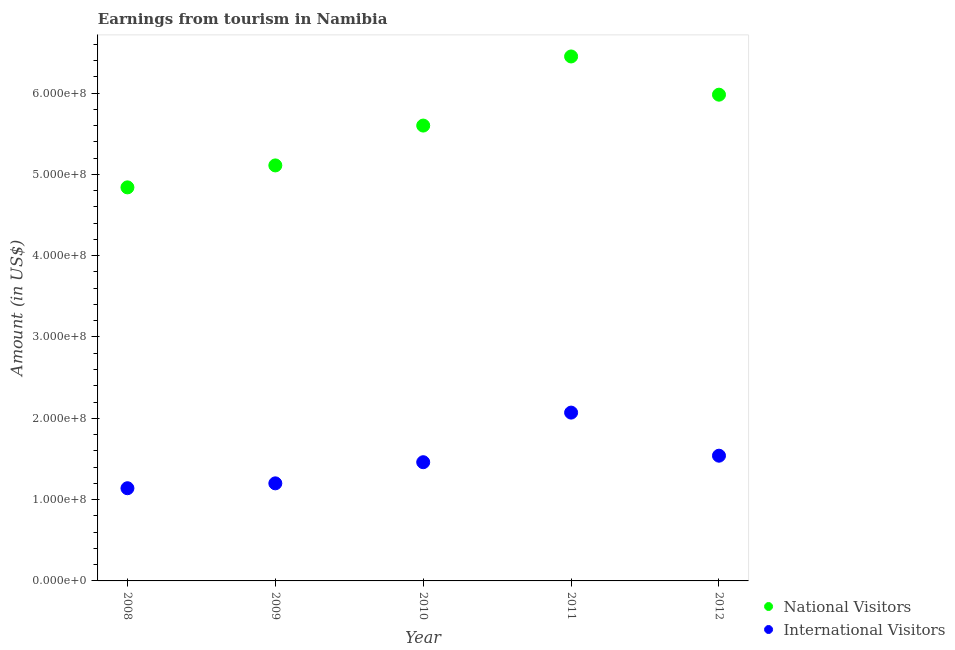How many different coloured dotlines are there?
Provide a succinct answer. 2. Is the number of dotlines equal to the number of legend labels?
Your answer should be very brief. Yes. What is the amount earned from international visitors in 2008?
Your answer should be compact. 1.14e+08. Across all years, what is the maximum amount earned from national visitors?
Ensure brevity in your answer.  6.45e+08. Across all years, what is the minimum amount earned from national visitors?
Offer a very short reply. 4.84e+08. In which year was the amount earned from national visitors maximum?
Offer a terse response. 2011. What is the total amount earned from national visitors in the graph?
Keep it short and to the point. 2.80e+09. What is the difference between the amount earned from international visitors in 2010 and that in 2012?
Your answer should be very brief. -8.00e+06. What is the difference between the amount earned from national visitors in 2011 and the amount earned from international visitors in 2010?
Make the answer very short. 4.99e+08. What is the average amount earned from international visitors per year?
Provide a succinct answer. 1.48e+08. In the year 2010, what is the difference between the amount earned from international visitors and amount earned from national visitors?
Give a very brief answer. -4.14e+08. What is the ratio of the amount earned from national visitors in 2008 to that in 2011?
Your answer should be compact. 0.75. What is the difference between the highest and the second highest amount earned from international visitors?
Ensure brevity in your answer.  5.30e+07. What is the difference between the highest and the lowest amount earned from national visitors?
Keep it short and to the point. 1.61e+08. In how many years, is the amount earned from national visitors greater than the average amount earned from national visitors taken over all years?
Give a very brief answer. 3. Is the sum of the amount earned from international visitors in 2008 and 2012 greater than the maximum amount earned from national visitors across all years?
Offer a terse response. No. Does the amount earned from international visitors monotonically increase over the years?
Make the answer very short. No. How many years are there in the graph?
Give a very brief answer. 5. What is the difference between two consecutive major ticks on the Y-axis?
Offer a terse response. 1.00e+08. Are the values on the major ticks of Y-axis written in scientific E-notation?
Provide a short and direct response. Yes. Does the graph contain any zero values?
Offer a very short reply. No. Where does the legend appear in the graph?
Give a very brief answer. Bottom right. How many legend labels are there?
Provide a succinct answer. 2. What is the title of the graph?
Ensure brevity in your answer.  Earnings from tourism in Namibia. Does "Rural" appear as one of the legend labels in the graph?
Provide a short and direct response. No. What is the Amount (in US$) of National Visitors in 2008?
Offer a very short reply. 4.84e+08. What is the Amount (in US$) of International Visitors in 2008?
Keep it short and to the point. 1.14e+08. What is the Amount (in US$) in National Visitors in 2009?
Provide a succinct answer. 5.11e+08. What is the Amount (in US$) in International Visitors in 2009?
Your answer should be compact. 1.20e+08. What is the Amount (in US$) of National Visitors in 2010?
Make the answer very short. 5.60e+08. What is the Amount (in US$) of International Visitors in 2010?
Provide a succinct answer. 1.46e+08. What is the Amount (in US$) in National Visitors in 2011?
Keep it short and to the point. 6.45e+08. What is the Amount (in US$) of International Visitors in 2011?
Provide a short and direct response. 2.07e+08. What is the Amount (in US$) of National Visitors in 2012?
Your answer should be very brief. 5.98e+08. What is the Amount (in US$) of International Visitors in 2012?
Provide a short and direct response. 1.54e+08. Across all years, what is the maximum Amount (in US$) of National Visitors?
Ensure brevity in your answer.  6.45e+08. Across all years, what is the maximum Amount (in US$) in International Visitors?
Make the answer very short. 2.07e+08. Across all years, what is the minimum Amount (in US$) of National Visitors?
Give a very brief answer. 4.84e+08. Across all years, what is the minimum Amount (in US$) of International Visitors?
Your answer should be very brief. 1.14e+08. What is the total Amount (in US$) in National Visitors in the graph?
Keep it short and to the point. 2.80e+09. What is the total Amount (in US$) in International Visitors in the graph?
Offer a very short reply. 7.41e+08. What is the difference between the Amount (in US$) in National Visitors in 2008 and that in 2009?
Keep it short and to the point. -2.70e+07. What is the difference between the Amount (in US$) in International Visitors in 2008 and that in 2009?
Make the answer very short. -6.00e+06. What is the difference between the Amount (in US$) in National Visitors in 2008 and that in 2010?
Your response must be concise. -7.60e+07. What is the difference between the Amount (in US$) in International Visitors in 2008 and that in 2010?
Offer a very short reply. -3.20e+07. What is the difference between the Amount (in US$) of National Visitors in 2008 and that in 2011?
Your answer should be very brief. -1.61e+08. What is the difference between the Amount (in US$) in International Visitors in 2008 and that in 2011?
Your answer should be very brief. -9.30e+07. What is the difference between the Amount (in US$) of National Visitors in 2008 and that in 2012?
Give a very brief answer. -1.14e+08. What is the difference between the Amount (in US$) in International Visitors in 2008 and that in 2012?
Your answer should be very brief. -4.00e+07. What is the difference between the Amount (in US$) in National Visitors in 2009 and that in 2010?
Offer a very short reply. -4.90e+07. What is the difference between the Amount (in US$) of International Visitors in 2009 and that in 2010?
Provide a succinct answer. -2.60e+07. What is the difference between the Amount (in US$) of National Visitors in 2009 and that in 2011?
Your response must be concise. -1.34e+08. What is the difference between the Amount (in US$) of International Visitors in 2009 and that in 2011?
Keep it short and to the point. -8.70e+07. What is the difference between the Amount (in US$) in National Visitors in 2009 and that in 2012?
Your answer should be compact. -8.70e+07. What is the difference between the Amount (in US$) in International Visitors in 2009 and that in 2012?
Give a very brief answer. -3.40e+07. What is the difference between the Amount (in US$) in National Visitors in 2010 and that in 2011?
Give a very brief answer. -8.50e+07. What is the difference between the Amount (in US$) in International Visitors in 2010 and that in 2011?
Your answer should be very brief. -6.10e+07. What is the difference between the Amount (in US$) in National Visitors in 2010 and that in 2012?
Offer a terse response. -3.80e+07. What is the difference between the Amount (in US$) of International Visitors in 2010 and that in 2012?
Offer a terse response. -8.00e+06. What is the difference between the Amount (in US$) in National Visitors in 2011 and that in 2012?
Give a very brief answer. 4.70e+07. What is the difference between the Amount (in US$) in International Visitors in 2011 and that in 2012?
Offer a very short reply. 5.30e+07. What is the difference between the Amount (in US$) in National Visitors in 2008 and the Amount (in US$) in International Visitors in 2009?
Your response must be concise. 3.64e+08. What is the difference between the Amount (in US$) of National Visitors in 2008 and the Amount (in US$) of International Visitors in 2010?
Provide a short and direct response. 3.38e+08. What is the difference between the Amount (in US$) of National Visitors in 2008 and the Amount (in US$) of International Visitors in 2011?
Give a very brief answer. 2.77e+08. What is the difference between the Amount (in US$) of National Visitors in 2008 and the Amount (in US$) of International Visitors in 2012?
Offer a very short reply. 3.30e+08. What is the difference between the Amount (in US$) of National Visitors in 2009 and the Amount (in US$) of International Visitors in 2010?
Your response must be concise. 3.65e+08. What is the difference between the Amount (in US$) in National Visitors in 2009 and the Amount (in US$) in International Visitors in 2011?
Ensure brevity in your answer.  3.04e+08. What is the difference between the Amount (in US$) of National Visitors in 2009 and the Amount (in US$) of International Visitors in 2012?
Your answer should be very brief. 3.57e+08. What is the difference between the Amount (in US$) in National Visitors in 2010 and the Amount (in US$) in International Visitors in 2011?
Your answer should be compact. 3.53e+08. What is the difference between the Amount (in US$) of National Visitors in 2010 and the Amount (in US$) of International Visitors in 2012?
Your answer should be compact. 4.06e+08. What is the difference between the Amount (in US$) of National Visitors in 2011 and the Amount (in US$) of International Visitors in 2012?
Make the answer very short. 4.91e+08. What is the average Amount (in US$) of National Visitors per year?
Your answer should be very brief. 5.60e+08. What is the average Amount (in US$) of International Visitors per year?
Ensure brevity in your answer.  1.48e+08. In the year 2008, what is the difference between the Amount (in US$) of National Visitors and Amount (in US$) of International Visitors?
Give a very brief answer. 3.70e+08. In the year 2009, what is the difference between the Amount (in US$) of National Visitors and Amount (in US$) of International Visitors?
Provide a short and direct response. 3.91e+08. In the year 2010, what is the difference between the Amount (in US$) in National Visitors and Amount (in US$) in International Visitors?
Your answer should be very brief. 4.14e+08. In the year 2011, what is the difference between the Amount (in US$) of National Visitors and Amount (in US$) of International Visitors?
Keep it short and to the point. 4.38e+08. In the year 2012, what is the difference between the Amount (in US$) of National Visitors and Amount (in US$) of International Visitors?
Offer a very short reply. 4.44e+08. What is the ratio of the Amount (in US$) of National Visitors in 2008 to that in 2009?
Offer a terse response. 0.95. What is the ratio of the Amount (in US$) of International Visitors in 2008 to that in 2009?
Your answer should be very brief. 0.95. What is the ratio of the Amount (in US$) in National Visitors in 2008 to that in 2010?
Make the answer very short. 0.86. What is the ratio of the Amount (in US$) in International Visitors in 2008 to that in 2010?
Your answer should be very brief. 0.78. What is the ratio of the Amount (in US$) in National Visitors in 2008 to that in 2011?
Your answer should be compact. 0.75. What is the ratio of the Amount (in US$) in International Visitors in 2008 to that in 2011?
Provide a succinct answer. 0.55. What is the ratio of the Amount (in US$) in National Visitors in 2008 to that in 2012?
Keep it short and to the point. 0.81. What is the ratio of the Amount (in US$) in International Visitors in 2008 to that in 2012?
Give a very brief answer. 0.74. What is the ratio of the Amount (in US$) in National Visitors in 2009 to that in 2010?
Make the answer very short. 0.91. What is the ratio of the Amount (in US$) of International Visitors in 2009 to that in 2010?
Provide a short and direct response. 0.82. What is the ratio of the Amount (in US$) in National Visitors in 2009 to that in 2011?
Your response must be concise. 0.79. What is the ratio of the Amount (in US$) of International Visitors in 2009 to that in 2011?
Make the answer very short. 0.58. What is the ratio of the Amount (in US$) of National Visitors in 2009 to that in 2012?
Make the answer very short. 0.85. What is the ratio of the Amount (in US$) in International Visitors in 2009 to that in 2012?
Your response must be concise. 0.78. What is the ratio of the Amount (in US$) in National Visitors in 2010 to that in 2011?
Offer a terse response. 0.87. What is the ratio of the Amount (in US$) of International Visitors in 2010 to that in 2011?
Keep it short and to the point. 0.71. What is the ratio of the Amount (in US$) in National Visitors in 2010 to that in 2012?
Offer a very short reply. 0.94. What is the ratio of the Amount (in US$) of International Visitors in 2010 to that in 2012?
Keep it short and to the point. 0.95. What is the ratio of the Amount (in US$) of National Visitors in 2011 to that in 2012?
Keep it short and to the point. 1.08. What is the ratio of the Amount (in US$) in International Visitors in 2011 to that in 2012?
Make the answer very short. 1.34. What is the difference between the highest and the second highest Amount (in US$) in National Visitors?
Ensure brevity in your answer.  4.70e+07. What is the difference between the highest and the second highest Amount (in US$) in International Visitors?
Offer a terse response. 5.30e+07. What is the difference between the highest and the lowest Amount (in US$) in National Visitors?
Your answer should be compact. 1.61e+08. What is the difference between the highest and the lowest Amount (in US$) in International Visitors?
Offer a terse response. 9.30e+07. 